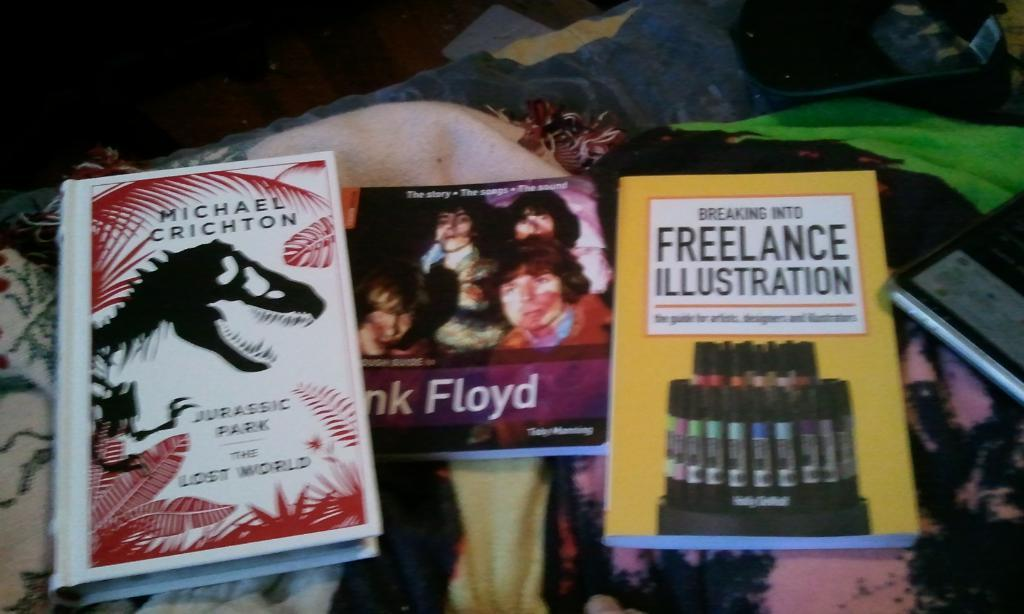<image>
Summarize the visual content of the image. The famous band pink Floyd is on the book in the middle. 